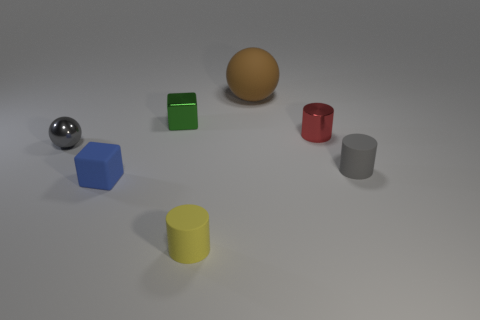There is a blue block that is the same size as the gray ball; what material is it?
Ensure brevity in your answer.  Rubber. What size is the block that is made of the same material as the yellow cylinder?
Provide a succinct answer. Small. What is the color of the big ball?
Make the answer very short. Brown. There is a gray thing that is the same shape as the brown matte object; what is its material?
Provide a succinct answer. Metal. There is a matte thing that is on the right side of the tiny metal object on the right side of the small green object; what is its shape?
Your answer should be compact. Cylinder. What is the shape of the yellow object that is the same material as the brown object?
Give a very brief answer. Cylinder. How many other things are there of the same shape as the big thing?
Your response must be concise. 1. Does the thing left of the blue object have the same size as the tiny blue rubber block?
Keep it short and to the point. Yes. Is the number of gray objects in front of the gray ball greater than the number of small blue cylinders?
Keep it short and to the point. Yes. There is a metal thing that is on the right side of the yellow cylinder; how many yellow rubber cylinders are behind it?
Give a very brief answer. 0. 